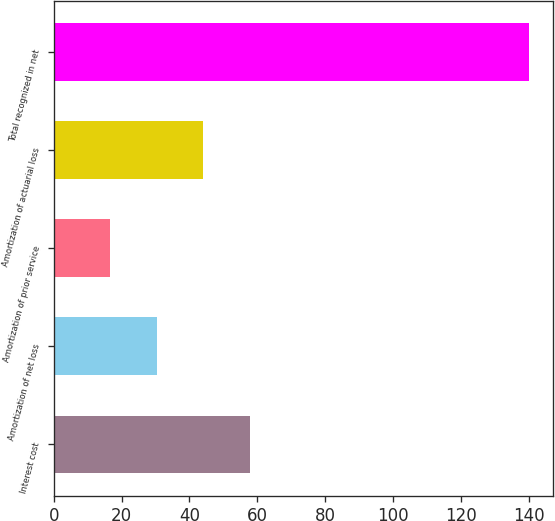Convert chart to OTSL. <chart><loc_0><loc_0><loc_500><loc_500><bar_chart><fcel>Interest cost<fcel>Amortization of net loss<fcel>Amortization of prior service<fcel>Amortization of actuarial loss<fcel>Total recognized in net<nl><fcel>57.8<fcel>30.4<fcel>16.7<fcel>44.1<fcel>140<nl></chart> 